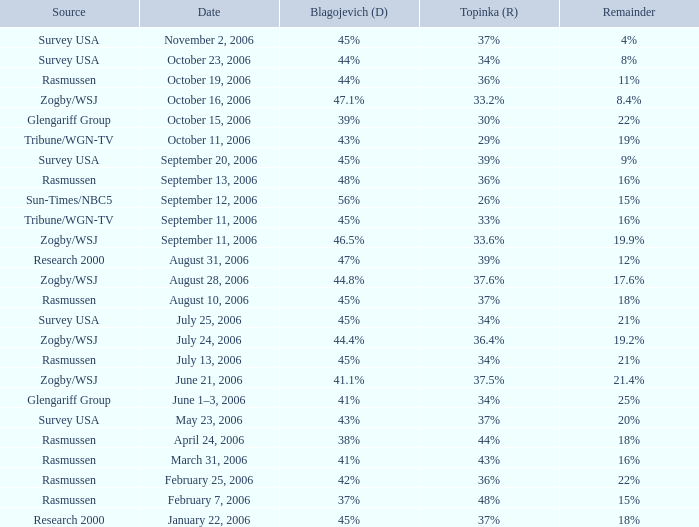2%? 47.1%. 